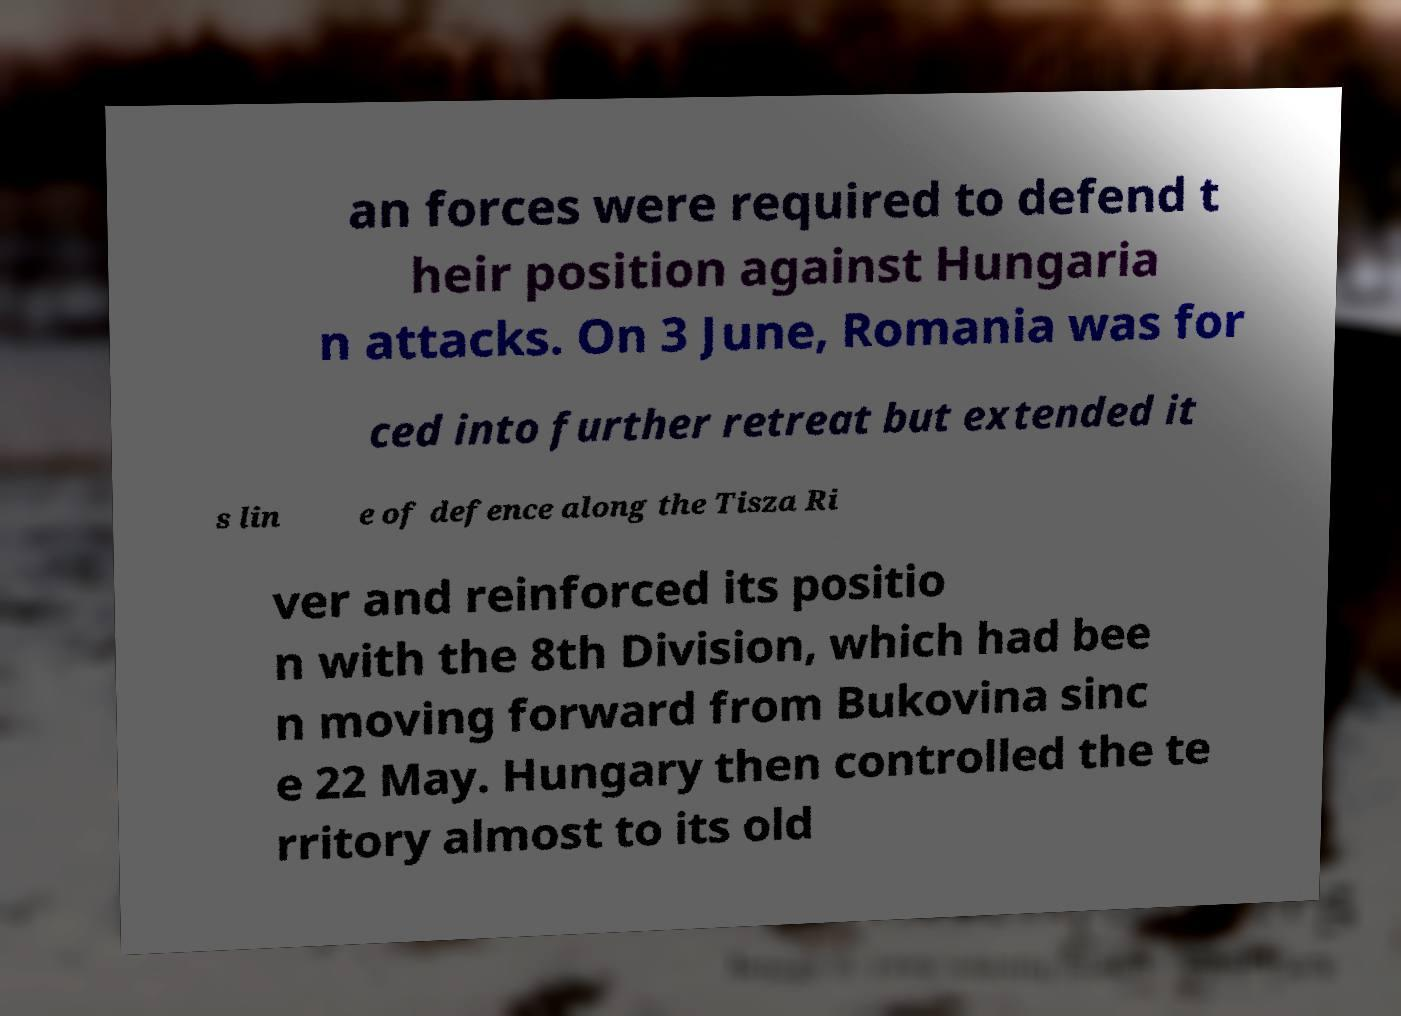What messages or text are displayed in this image? I need them in a readable, typed format. an forces were required to defend t heir position against Hungaria n attacks. On 3 June, Romania was for ced into further retreat but extended it s lin e of defence along the Tisza Ri ver and reinforced its positio n with the 8th Division, which had bee n moving forward from Bukovina sinc e 22 May. Hungary then controlled the te rritory almost to its old 